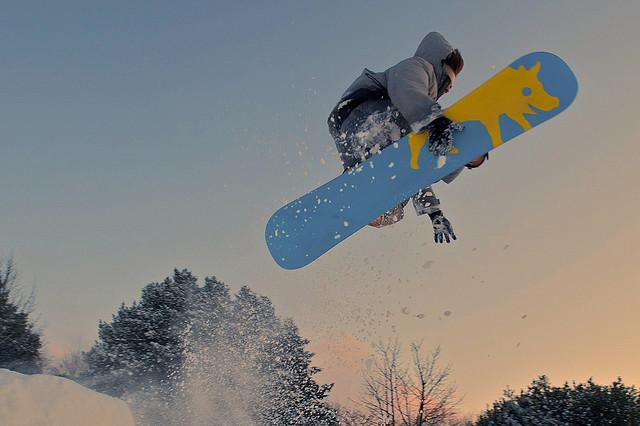How many trees are in the background?
Write a very short answer. 4. Is it snowing?
Write a very short answer. No. Does the man have on bright colors?
Concise answer only. No. Is the person laying down?
Answer briefly. No. What color is the snowboard?
Answer briefly. Blue. 